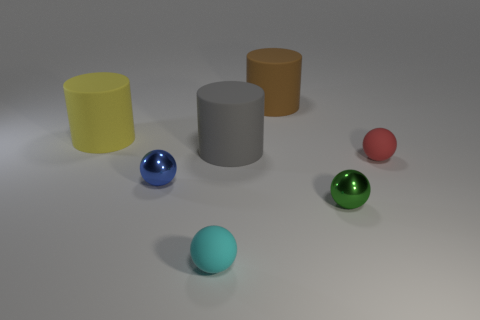Subtract all red rubber balls. How many balls are left? 3 Subtract all cyan spheres. How many spheres are left? 3 Subtract 2 balls. How many balls are left? 2 Add 2 large green objects. How many objects exist? 9 Subtract all cylinders. How many objects are left? 4 Add 5 small spheres. How many small spheres exist? 9 Subtract 1 brown cylinders. How many objects are left? 6 Subtract all purple balls. Subtract all green blocks. How many balls are left? 4 Subtract all yellow spheres. How many brown cylinders are left? 1 Subtract all small green objects. Subtract all big yellow objects. How many objects are left? 5 